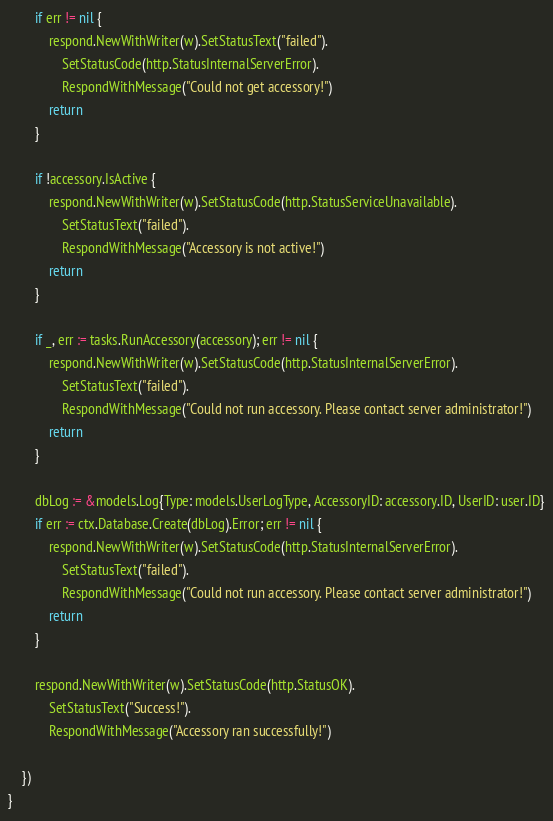Convert code to text. <code><loc_0><loc_0><loc_500><loc_500><_Go_>
		if err != nil {
			respond.NewWithWriter(w).SetStatusText("failed").
				SetStatusCode(http.StatusInternalServerError).
				RespondWithMessage("Could not get accessory!")
			return
		}

		if !accessory.IsActive {
			respond.NewWithWriter(w).SetStatusCode(http.StatusServiceUnavailable).
				SetStatusText("failed").
				RespondWithMessage("Accessory is not active!")
			return
		}

		if _, err := tasks.RunAccessory(accessory); err != nil {
			respond.NewWithWriter(w).SetStatusCode(http.StatusInternalServerError).
				SetStatusText("failed").
				RespondWithMessage("Could not run accessory. Please contact server administrator!")
			return
		}

		dbLog := &models.Log{Type: models.UserLogType, AccessoryID: accessory.ID, UserID: user.ID}
		if err := ctx.Database.Create(dbLog).Error; err != nil {
			respond.NewWithWriter(w).SetStatusCode(http.StatusInternalServerError).
				SetStatusText("failed").
				RespondWithMessage("Could not run accessory. Please contact server administrator!")
			return
		}

		respond.NewWithWriter(w).SetStatusCode(http.StatusOK).
			SetStatusText("Success!").
			RespondWithMessage("Accessory ran successfully!")

	})
}
</code> 